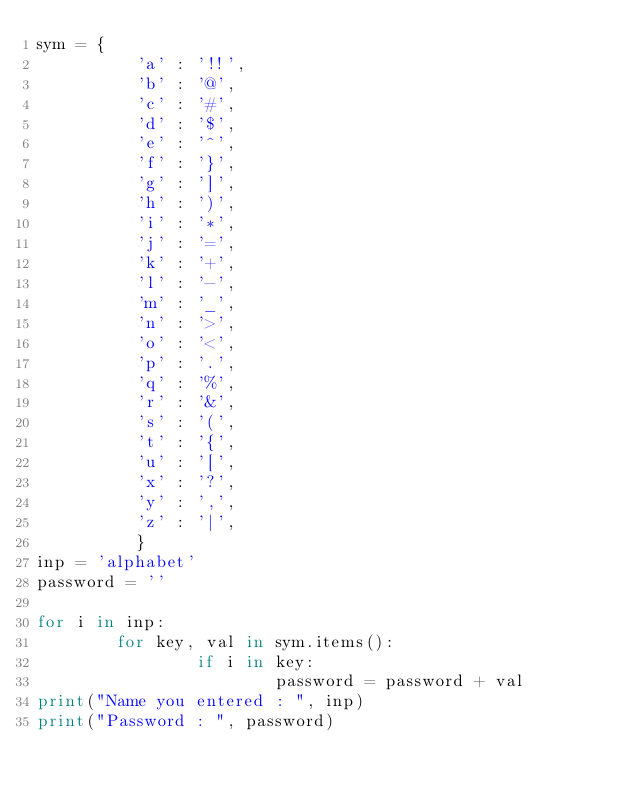Convert code to text. <code><loc_0><loc_0><loc_500><loc_500><_Python_>sym = {
          'a' : '!!',
          'b' : '@',
          'c' : '#',
          'd' : '$',
          'e' : '^',
          'f' : '}',
          'g' : ']',
          'h' : ')',
          'i' : '*',
          'j' : '=',
          'k' : '+',
          'l' : '-',
          'm' : '_',
          'n' : '>',
          'o' : '<',
          'p' : '.',
          'q' : '%',
          'r' : '&',
          's' : '(',
          't' : '{',
          'u' : '[',
          'x' : '?',
          'y' : ',',
          'z' : '|',
          }
inp = 'alphabet'
password = ''

for i in inp:
        for key, val in sym.items():
                if i in key:
                        password = password + val
print("Name you entered : ", inp)
print("Password : ", password)</code> 